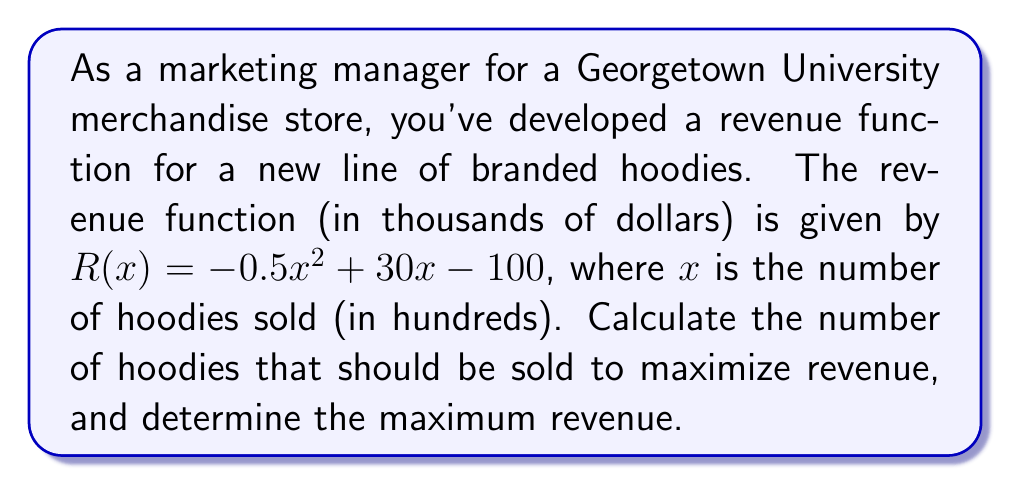Can you answer this question? To find the maximum revenue point, we need to follow these steps:

1. The revenue function is a quadratic polynomial: $R(x) = -0.5x^2 + 30x - 100$

2. To find the maximum point, we need to calculate the vertex of the parabola. For a quadratic function in the form $ax^2 + bx + c$, the x-coordinate of the vertex is given by $x = -\frac{b}{2a}$

3. In this case, $a = -0.5$ and $b = 30$. Let's calculate:

   $x = -\frac{30}{2(-0.5)} = -\frac{30}{-1} = 30$

4. This means the maximum revenue occurs when 30 hundred hoodies (or 3,000 hoodies) are sold.

5. To find the maximum revenue, we substitute $x = 30$ into the original function:

   $R(30) = -0.5(30)^2 + 30(30) - 100$
   $= -0.5(900) + 900 - 100$
   $= -450 + 900 - 100$
   $= 350$

6. The maximum revenue is $350,000 (remember, the function was in thousands of dollars).
Answer: 3,000 hoodies; $350,000 